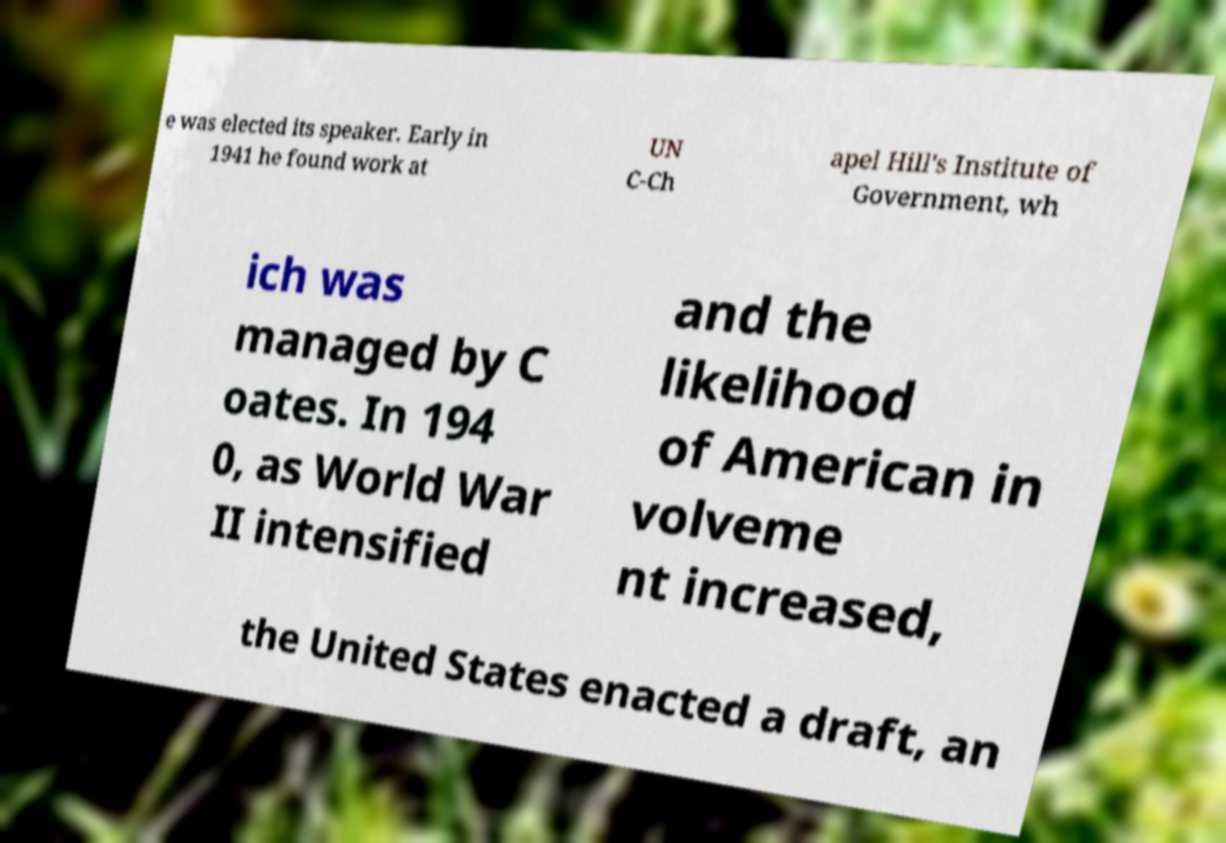Can you accurately transcribe the text from the provided image for me? e was elected its speaker. Early in 1941 he found work at UN C-Ch apel Hill's Institute of Government, wh ich was managed by C oates. In 194 0, as World War II intensified and the likelihood of American in volveme nt increased, the United States enacted a draft, an 